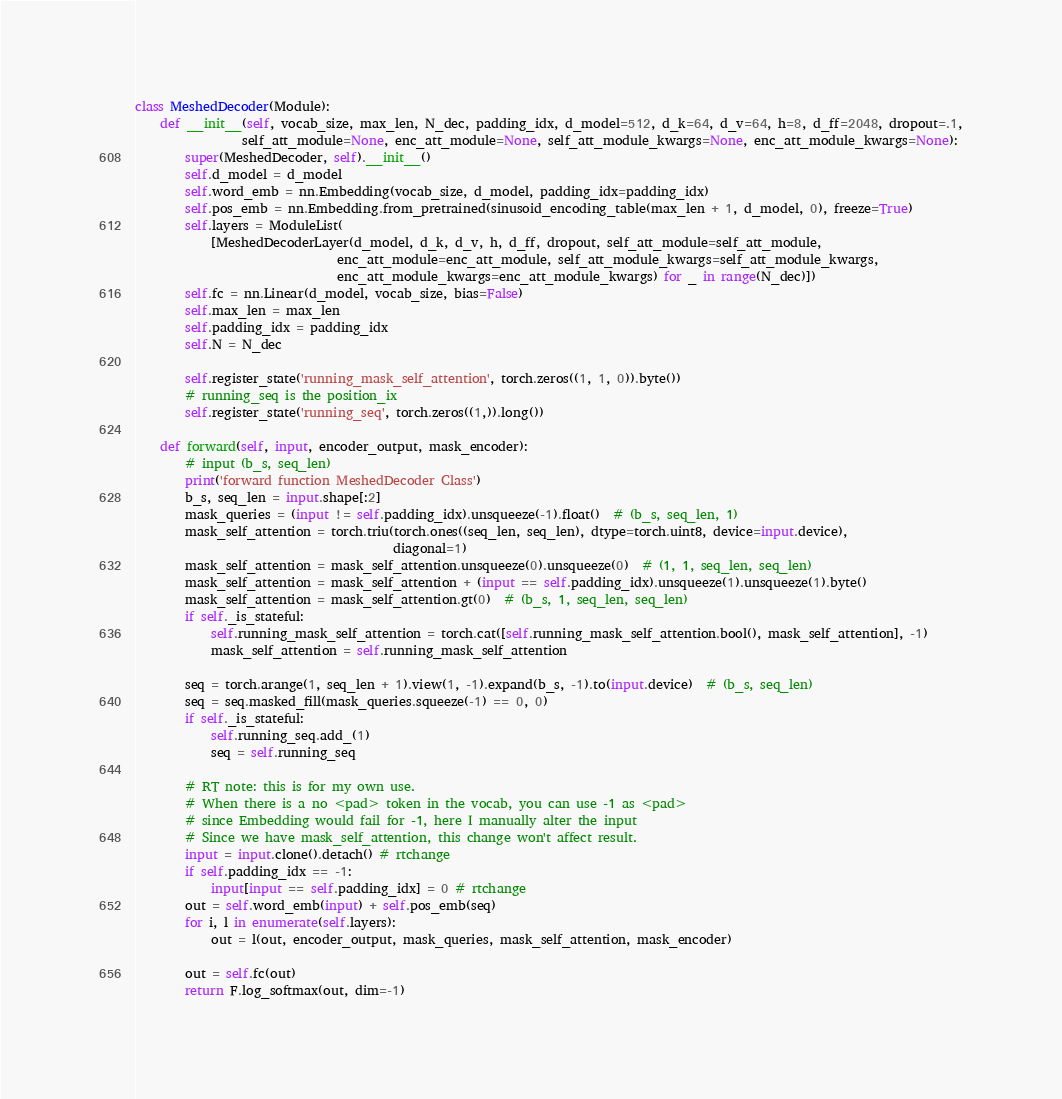<code> <loc_0><loc_0><loc_500><loc_500><_Python_>
class MeshedDecoder(Module):
    def __init__(self, vocab_size, max_len, N_dec, padding_idx, d_model=512, d_k=64, d_v=64, h=8, d_ff=2048, dropout=.1,
                 self_att_module=None, enc_att_module=None, self_att_module_kwargs=None, enc_att_module_kwargs=None):
        super(MeshedDecoder, self).__init__()
        self.d_model = d_model
        self.word_emb = nn.Embedding(vocab_size, d_model, padding_idx=padding_idx)
        self.pos_emb = nn.Embedding.from_pretrained(sinusoid_encoding_table(max_len + 1, d_model, 0), freeze=True)
        self.layers = ModuleList(
            [MeshedDecoderLayer(d_model, d_k, d_v, h, d_ff, dropout, self_att_module=self_att_module,
                                enc_att_module=enc_att_module, self_att_module_kwargs=self_att_module_kwargs,
                                enc_att_module_kwargs=enc_att_module_kwargs) for _ in range(N_dec)])
        self.fc = nn.Linear(d_model, vocab_size, bias=False)
        self.max_len = max_len
        self.padding_idx = padding_idx
        self.N = N_dec

        self.register_state('running_mask_self_attention', torch.zeros((1, 1, 0)).byte())
        # running_seq is the position_ix
        self.register_state('running_seq', torch.zeros((1,)).long())

    def forward(self, input, encoder_output, mask_encoder):
        # input (b_s, seq_len)
        print('forward function MeshedDecoder Class')
        b_s, seq_len = input.shape[:2]
        mask_queries = (input != self.padding_idx).unsqueeze(-1).float()  # (b_s, seq_len, 1)
        mask_self_attention = torch.triu(torch.ones((seq_len, seq_len), dtype=torch.uint8, device=input.device),
                                         diagonal=1)
        mask_self_attention = mask_self_attention.unsqueeze(0).unsqueeze(0)  # (1, 1, seq_len, seq_len)
        mask_self_attention = mask_self_attention + (input == self.padding_idx).unsqueeze(1).unsqueeze(1).byte()
        mask_self_attention = mask_self_attention.gt(0)  # (b_s, 1, seq_len, seq_len)
        if self._is_stateful:
            self.running_mask_self_attention = torch.cat([self.running_mask_self_attention.bool(), mask_self_attention], -1)
            mask_self_attention = self.running_mask_self_attention

        seq = torch.arange(1, seq_len + 1).view(1, -1).expand(b_s, -1).to(input.device)  # (b_s, seq_len)
        seq = seq.masked_fill(mask_queries.squeeze(-1) == 0, 0)
        if self._is_stateful:
            self.running_seq.add_(1)
            seq = self.running_seq

        # RT note: this is for my own use.
        # When there is a no <pad> token in the vocab, you can use -1 as <pad>
        # since Embedding would fail for -1, here I manually alter the input
        # Since we have mask_self_attention, this change won't affect result.
        input = input.clone().detach() # rtchange
        if self.padding_idx == -1:
            input[input == self.padding_idx] = 0 # rtchange
        out = self.word_emb(input) + self.pos_emb(seq)
        for i, l in enumerate(self.layers):
            out = l(out, encoder_output, mask_queries, mask_self_attention, mask_encoder)

        out = self.fc(out)
        return F.log_softmax(out, dim=-1)
</code> 